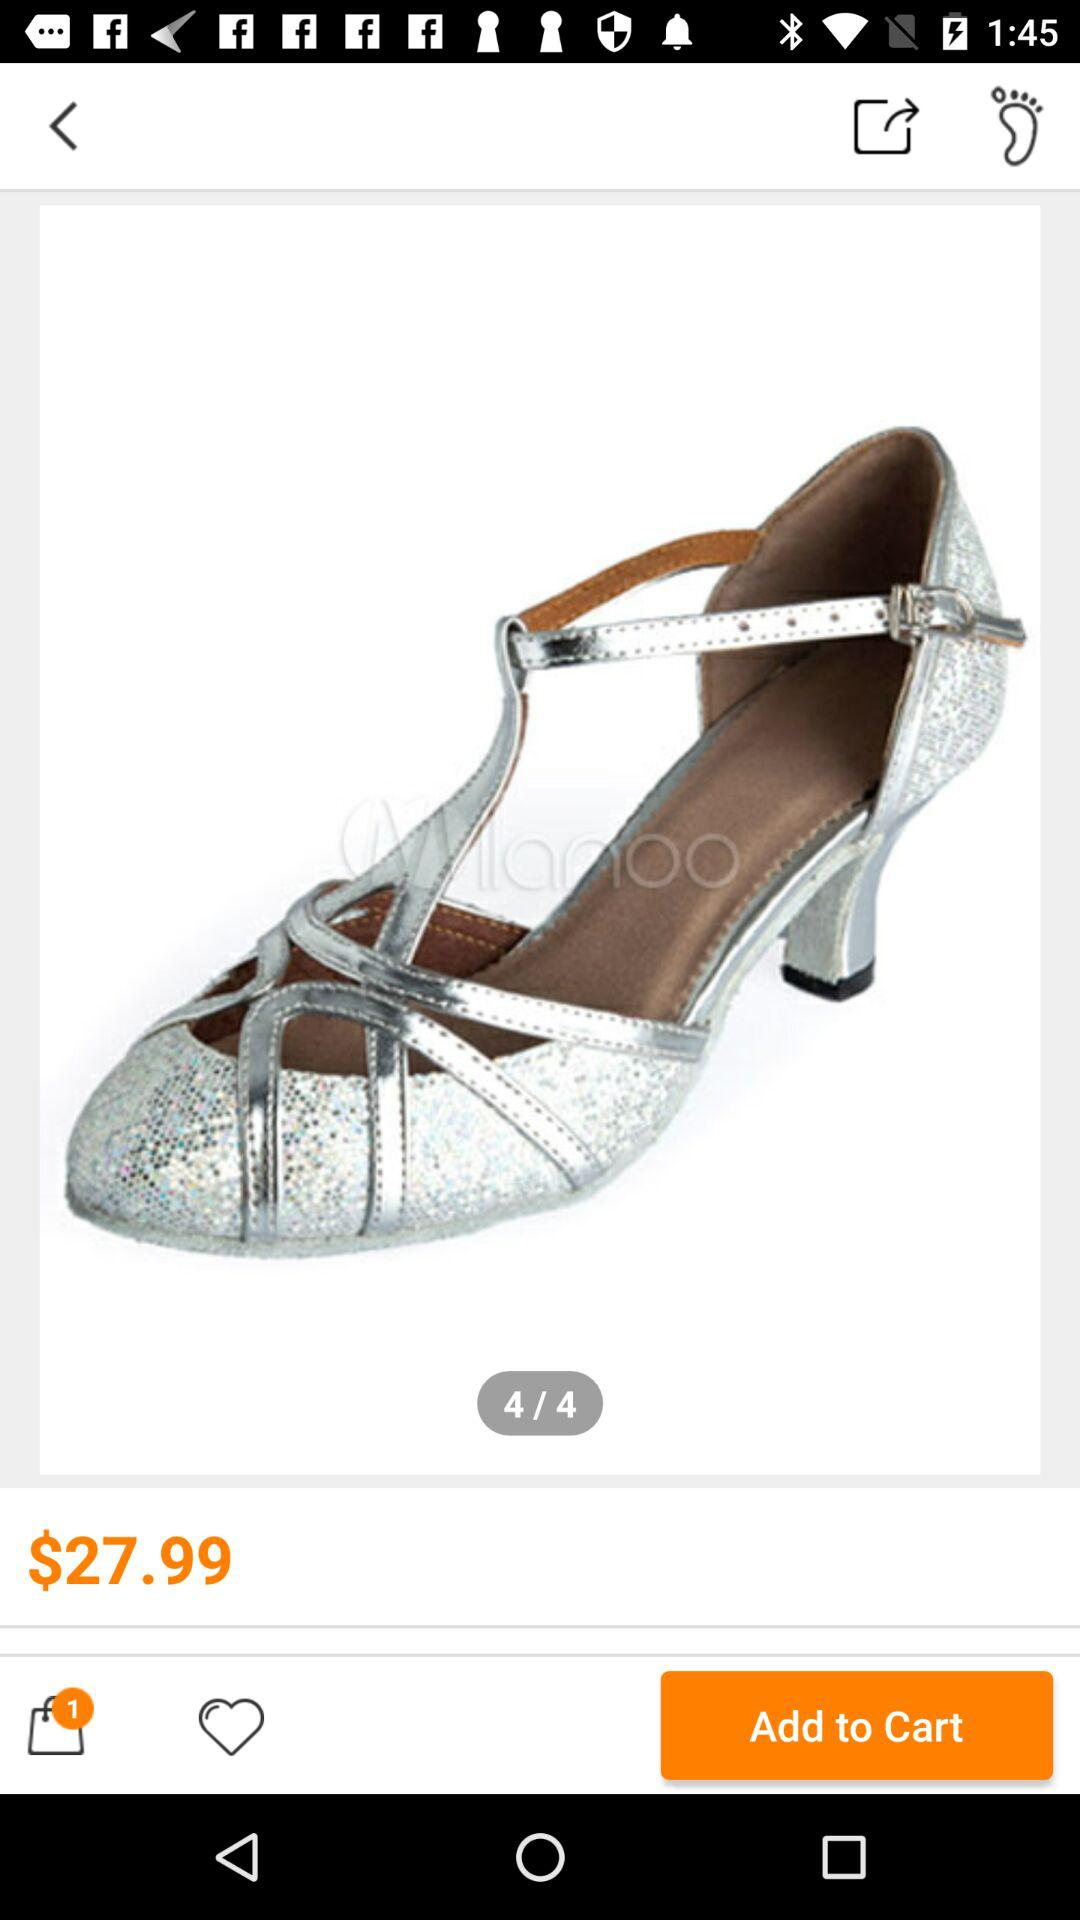How many images in total are there? The total number of images is 4. 